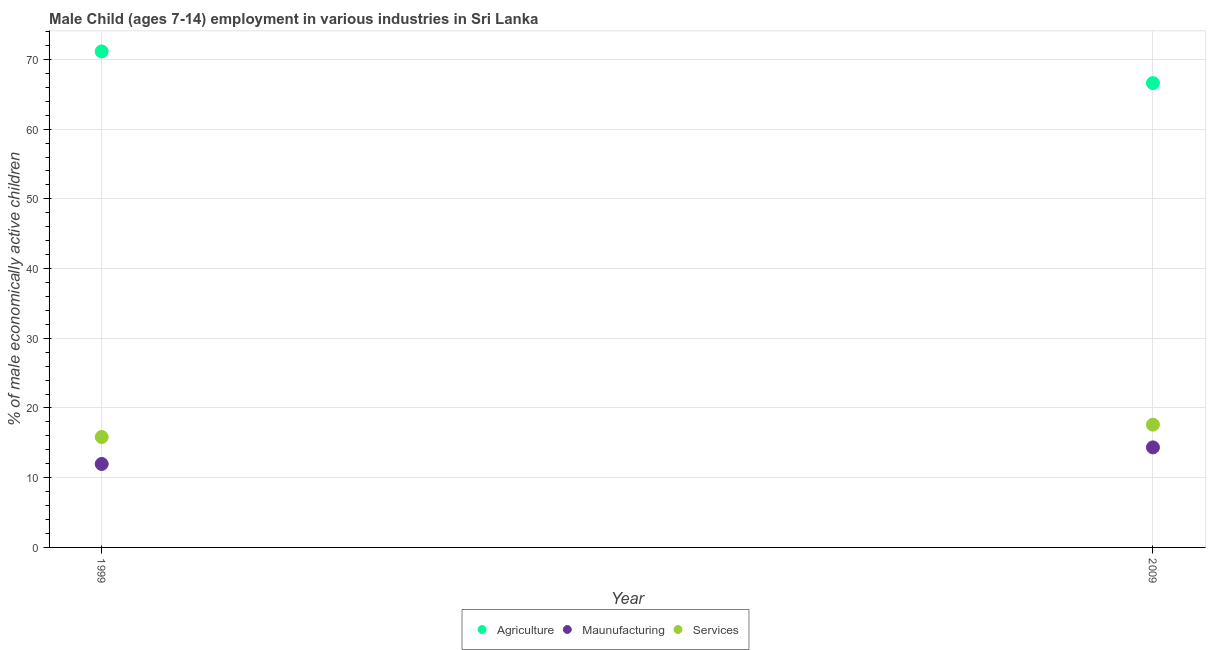Is the number of dotlines equal to the number of legend labels?
Provide a succinct answer. Yes. What is the percentage of economically active children in agriculture in 1999?
Your answer should be compact. 71.14. Across all years, what is the maximum percentage of economically active children in services?
Your answer should be compact. 17.61. Across all years, what is the minimum percentage of economically active children in manufacturing?
Give a very brief answer. 11.97. What is the total percentage of economically active children in manufacturing in the graph?
Offer a very short reply. 26.32. What is the difference between the percentage of economically active children in services in 1999 and that in 2009?
Give a very brief answer. -1.77. What is the difference between the percentage of economically active children in manufacturing in 1999 and the percentage of economically active children in services in 2009?
Your answer should be very brief. -5.64. What is the average percentage of economically active children in services per year?
Your answer should be compact. 16.73. In the year 2009, what is the difference between the percentage of economically active children in agriculture and percentage of economically active children in services?
Offer a terse response. 48.99. In how many years, is the percentage of economically active children in agriculture greater than 32 %?
Ensure brevity in your answer.  2. What is the ratio of the percentage of economically active children in services in 1999 to that in 2009?
Your response must be concise. 0.9. Is the percentage of economically active children in services in 1999 less than that in 2009?
Your answer should be very brief. Yes. Does the percentage of economically active children in manufacturing monotonically increase over the years?
Make the answer very short. Yes. Is the percentage of economically active children in agriculture strictly less than the percentage of economically active children in services over the years?
Your answer should be very brief. No. Are the values on the major ticks of Y-axis written in scientific E-notation?
Offer a very short reply. No. Does the graph contain any zero values?
Give a very brief answer. No. How many legend labels are there?
Offer a terse response. 3. How are the legend labels stacked?
Provide a succinct answer. Horizontal. What is the title of the graph?
Your answer should be very brief. Male Child (ages 7-14) employment in various industries in Sri Lanka. What is the label or title of the X-axis?
Offer a very short reply. Year. What is the label or title of the Y-axis?
Offer a terse response. % of male economically active children. What is the % of male economically active children in Agriculture in 1999?
Provide a succinct answer. 71.14. What is the % of male economically active children in Maunufacturing in 1999?
Provide a succinct answer. 11.97. What is the % of male economically active children in Services in 1999?
Your response must be concise. 15.84. What is the % of male economically active children in Agriculture in 2009?
Ensure brevity in your answer.  66.6. What is the % of male economically active children of Maunufacturing in 2009?
Give a very brief answer. 14.35. What is the % of male economically active children in Services in 2009?
Your response must be concise. 17.61. Across all years, what is the maximum % of male economically active children of Agriculture?
Provide a succinct answer. 71.14. Across all years, what is the maximum % of male economically active children of Maunufacturing?
Give a very brief answer. 14.35. Across all years, what is the maximum % of male economically active children in Services?
Provide a succinct answer. 17.61. Across all years, what is the minimum % of male economically active children of Agriculture?
Keep it short and to the point. 66.6. Across all years, what is the minimum % of male economically active children of Maunufacturing?
Your answer should be very brief. 11.97. Across all years, what is the minimum % of male economically active children in Services?
Make the answer very short. 15.84. What is the total % of male economically active children in Agriculture in the graph?
Provide a succinct answer. 137.74. What is the total % of male economically active children in Maunufacturing in the graph?
Make the answer very short. 26.32. What is the total % of male economically active children of Services in the graph?
Offer a terse response. 33.45. What is the difference between the % of male economically active children of Agriculture in 1999 and that in 2009?
Give a very brief answer. 4.54. What is the difference between the % of male economically active children in Maunufacturing in 1999 and that in 2009?
Offer a very short reply. -2.38. What is the difference between the % of male economically active children of Services in 1999 and that in 2009?
Your response must be concise. -1.77. What is the difference between the % of male economically active children in Agriculture in 1999 and the % of male economically active children in Maunufacturing in 2009?
Provide a succinct answer. 56.79. What is the difference between the % of male economically active children in Agriculture in 1999 and the % of male economically active children in Services in 2009?
Offer a very short reply. 53.53. What is the difference between the % of male economically active children of Maunufacturing in 1999 and the % of male economically active children of Services in 2009?
Your response must be concise. -5.64. What is the average % of male economically active children of Agriculture per year?
Keep it short and to the point. 68.87. What is the average % of male economically active children in Maunufacturing per year?
Make the answer very short. 13.16. What is the average % of male economically active children of Services per year?
Your answer should be compact. 16.73. In the year 1999, what is the difference between the % of male economically active children in Agriculture and % of male economically active children in Maunufacturing?
Provide a succinct answer. 59.17. In the year 1999, what is the difference between the % of male economically active children of Agriculture and % of male economically active children of Services?
Make the answer very short. 55.3. In the year 1999, what is the difference between the % of male economically active children in Maunufacturing and % of male economically active children in Services?
Provide a succinct answer. -3.87. In the year 2009, what is the difference between the % of male economically active children in Agriculture and % of male economically active children in Maunufacturing?
Ensure brevity in your answer.  52.25. In the year 2009, what is the difference between the % of male economically active children in Agriculture and % of male economically active children in Services?
Make the answer very short. 48.99. In the year 2009, what is the difference between the % of male economically active children in Maunufacturing and % of male economically active children in Services?
Your response must be concise. -3.26. What is the ratio of the % of male economically active children in Agriculture in 1999 to that in 2009?
Offer a terse response. 1.07. What is the ratio of the % of male economically active children in Maunufacturing in 1999 to that in 2009?
Your answer should be compact. 0.83. What is the ratio of the % of male economically active children of Services in 1999 to that in 2009?
Your answer should be very brief. 0.9. What is the difference between the highest and the second highest % of male economically active children in Agriculture?
Offer a terse response. 4.54. What is the difference between the highest and the second highest % of male economically active children in Maunufacturing?
Keep it short and to the point. 2.38. What is the difference between the highest and the second highest % of male economically active children in Services?
Make the answer very short. 1.77. What is the difference between the highest and the lowest % of male economically active children of Agriculture?
Give a very brief answer. 4.54. What is the difference between the highest and the lowest % of male economically active children in Maunufacturing?
Your answer should be compact. 2.38. What is the difference between the highest and the lowest % of male economically active children in Services?
Ensure brevity in your answer.  1.77. 